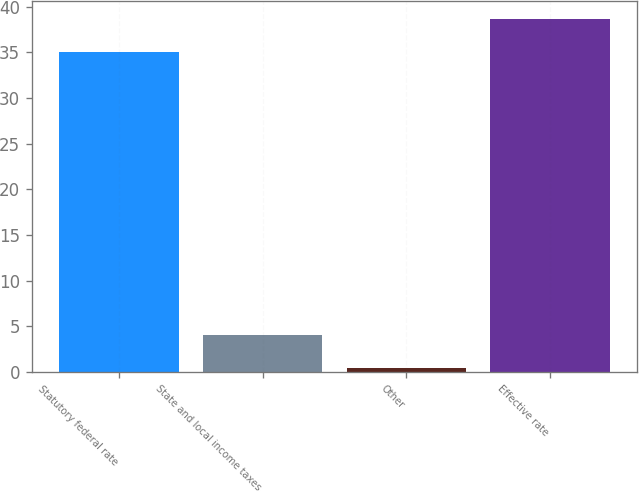Convert chart to OTSL. <chart><loc_0><loc_0><loc_500><loc_500><bar_chart><fcel>Statutory federal rate<fcel>State and local income taxes<fcel>Other<fcel>Effective rate<nl><fcel>35<fcel>4.08<fcel>0.4<fcel>38.68<nl></chart> 